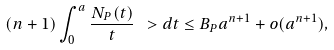<formula> <loc_0><loc_0><loc_500><loc_500>( n + 1 ) \int _ { 0 } ^ { a } \frac { N _ { P } ( t ) } { t } \ > d t \leq B _ { P } a ^ { n + 1 } + o ( a ^ { n + 1 } ) ,</formula> 